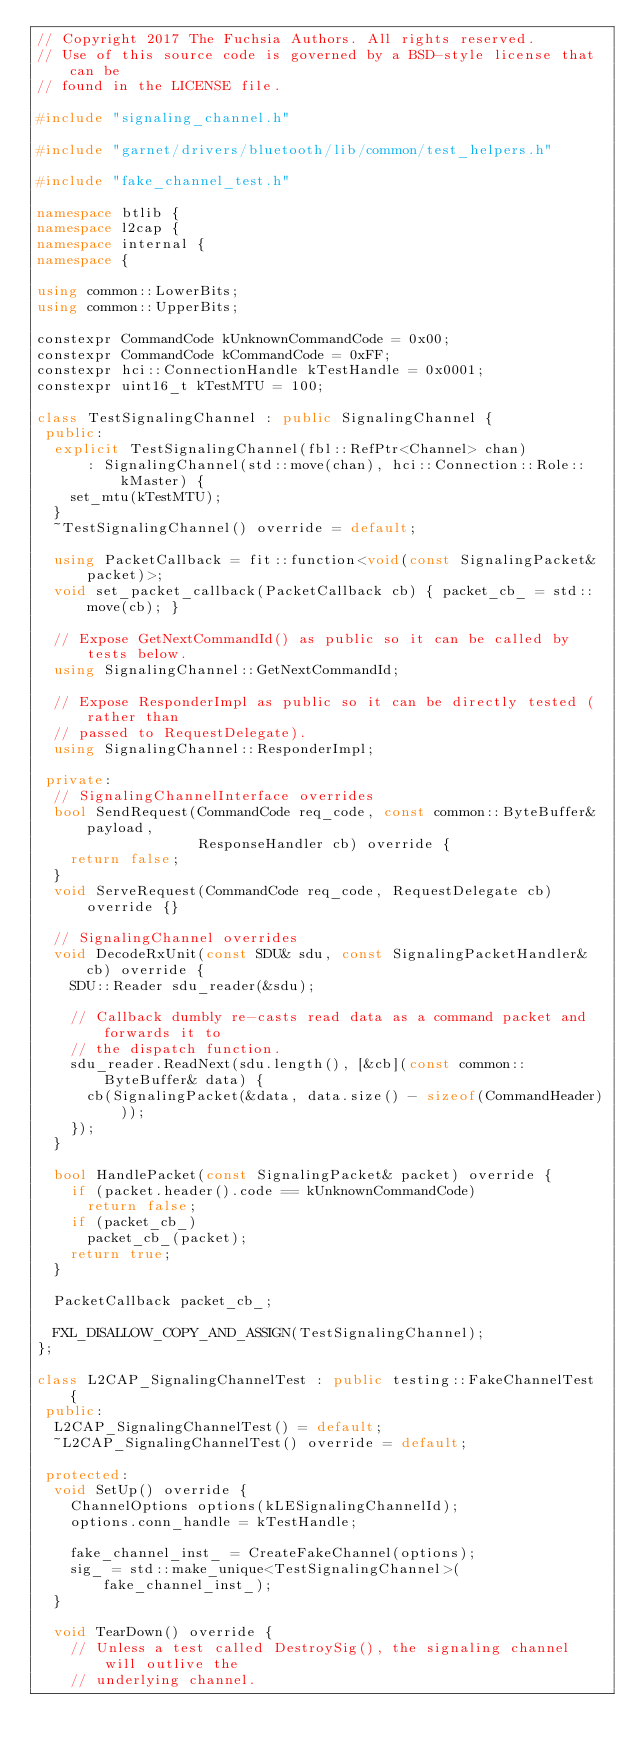Convert code to text. <code><loc_0><loc_0><loc_500><loc_500><_C++_>// Copyright 2017 The Fuchsia Authors. All rights reserved.
// Use of this source code is governed by a BSD-style license that can be
// found in the LICENSE file.

#include "signaling_channel.h"

#include "garnet/drivers/bluetooth/lib/common/test_helpers.h"

#include "fake_channel_test.h"

namespace btlib {
namespace l2cap {
namespace internal {
namespace {

using common::LowerBits;
using common::UpperBits;

constexpr CommandCode kUnknownCommandCode = 0x00;
constexpr CommandCode kCommandCode = 0xFF;
constexpr hci::ConnectionHandle kTestHandle = 0x0001;
constexpr uint16_t kTestMTU = 100;

class TestSignalingChannel : public SignalingChannel {
 public:
  explicit TestSignalingChannel(fbl::RefPtr<Channel> chan)
      : SignalingChannel(std::move(chan), hci::Connection::Role::kMaster) {
    set_mtu(kTestMTU);
  }
  ~TestSignalingChannel() override = default;

  using PacketCallback = fit::function<void(const SignalingPacket& packet)>;
  void set_packet_callback(PacketCallback cb) { packet_cb_ = std::move(cb); }

  // Expose GetNextCommandId() as public so it can be called by tests below.
  using SignalingChannel::GetNextCommandId;

  // Expose ResponderImpl as public so it can be directly tested (rather than
  // passed to RequestDelegate).
  using SignalingChannel::ResponderImpl;

 private:
  // SignalingChannelInterface overrides
  bool SendRequest(CommandCode req_code, const common::ByteBuffer& payload,
                   ResponseHandler cb) override {
    return false;
  }
  void ServeRequest(CommandCode req_code, RequestDelegate cb) override {}

  // SignalingChannel overrides
  void DecodeRxUnit(const SDU& sdu, const SignalingPacketHandler& cb) override {
    SDU::Reader sdu_reader(&sdu);

    // Callback dumbly re-casts read data as a command packet and forwards it to
    // the dispatch function.
    sdu_reader.ReadNext(sdu.length(), [&cb](const common::ByteBuffer& data) {
      cb(SignalingPacket(&data, data.size() - sizeof(CommandHeader)));
    });
  }

  bool HandlePacket(const SignalingPacket& packet) override {
    if (packet.header().code == kUnknownCommandCode)
      return false;
    if (packet_cb_)
      packet_cb_(packet);
    return true;
  }

  PacketCallback packet_cb_;

  FXL_DISALLOW_COPY_AND_ASSIGN(TestSignalingChannel);
};

class L2CAP_SignalingChannelTest : public testing::FakeChannelTest {
 public:
  L2CAP_SignalingChannelTest() = default;
  ~L2CAP_SignalingChannelTest() override = default;

 protected:
  void SetUp() override {
    ChannelOptions options(kLESignalingChannelId);
    options.conn_handle = kTestHandle;

    fake_channel_inst_ = CreateFakeChannel(options);
    sig_ = std::make_unique<TestSignalingChannel>(fake_channel_inst_);
  }

  void TearDown() override {
    // Unless a test called DestroySig(), the signaling channel will outlive the
    // underlying channel.</code> 